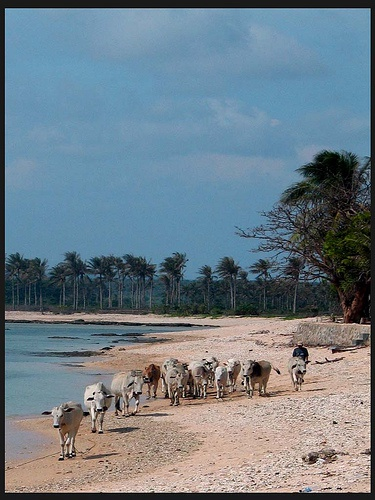Describe the objects in this image and their specific colors. I can see cow in black, gray, maroon, and darkgray tones, cow in black, darkgray, gray, and tan tones, cow in black, darkgray, gray, and lightgray tones, cow in black, maroon, and gray tones, and cow in black, darkgray, gray, and maroon tones in this image. 